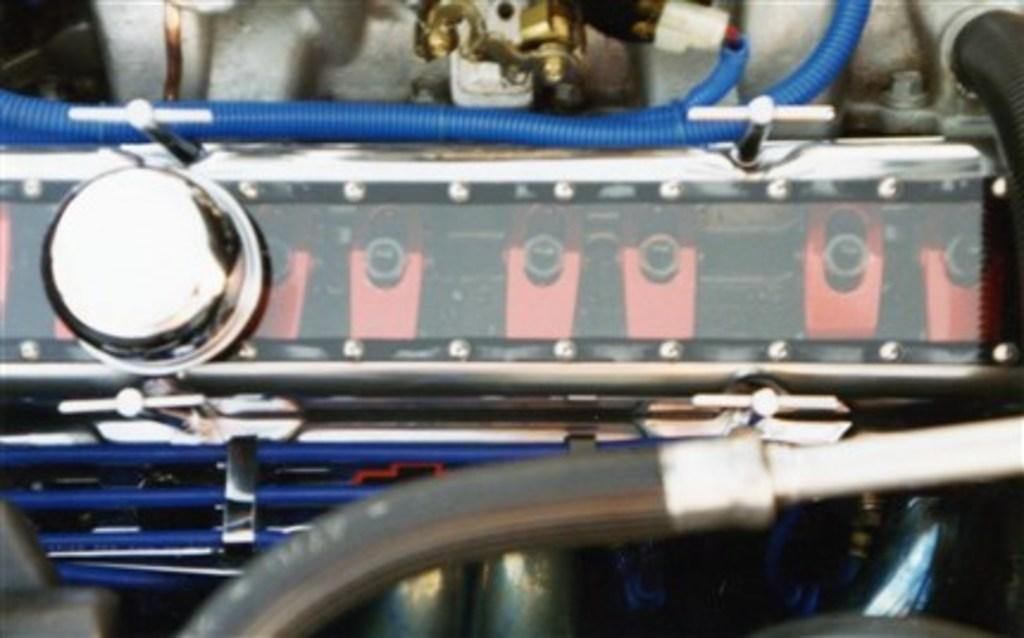What is the color of the button in the image? The button in the image is silver in color. What type of objects are the blue color pipes in the image? The blue color pipes in the image are objects. Can you describe any other objects in the image besides the button and pipes? Yes, there are other objects in the image, but their specific details are not mentioned in the provided facts. Is there a home visible in the image? There is no mention of a home in the provided facts, so it cannot be determined if a home is present in the image. 